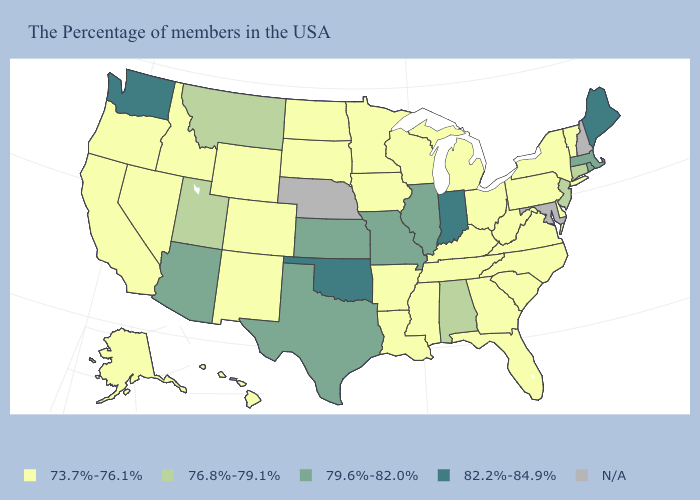How many symbols are there in the legend?
Write a very short answer. 5. Among the states that border Nebraska , does Kansas have the lowest value?
Short answer required. No. Among the states that border Michigan , does Ohio have the lowest value?
Short answer required. Yes. Name the states that have a value in the range 73.7%-76.1%?
Write a very short answer. Vermont, New York, Delaware, Pennsylvania, Virginia, North Carolina, South Carolina, West Virginia, Ohio, Florida, Georgia, Michigan, Kentucky, Tennessee, Wisconsin, Mississippi, Louisiana, Arkansas, Minnesota, Iowa, South Dakota, North Dakota, Wyoming, Colorado, New Mexico, Idaho, Nevada, California, Oregon, Alaska, Hawaii. Does Kentucky have the highest value in the South?
Answer briefly. No. What is the value of New Jersey?
Quick response, please. 76.8%-79.1%. Among the states that border Oklahoma , does New Mexico have the lowest value?
Quick response, please. Yes. Does Indiana have the highest value in the MidWest?
Be succinct. Yes. Does Rhode Island have the lowest value in the Northeast?
Give a very brief answer. No. What is the highest value in the South ?
Write a very short answer. 82.2%-84.9%. Does the map have missing data?
Write a very short answer. Yes. 